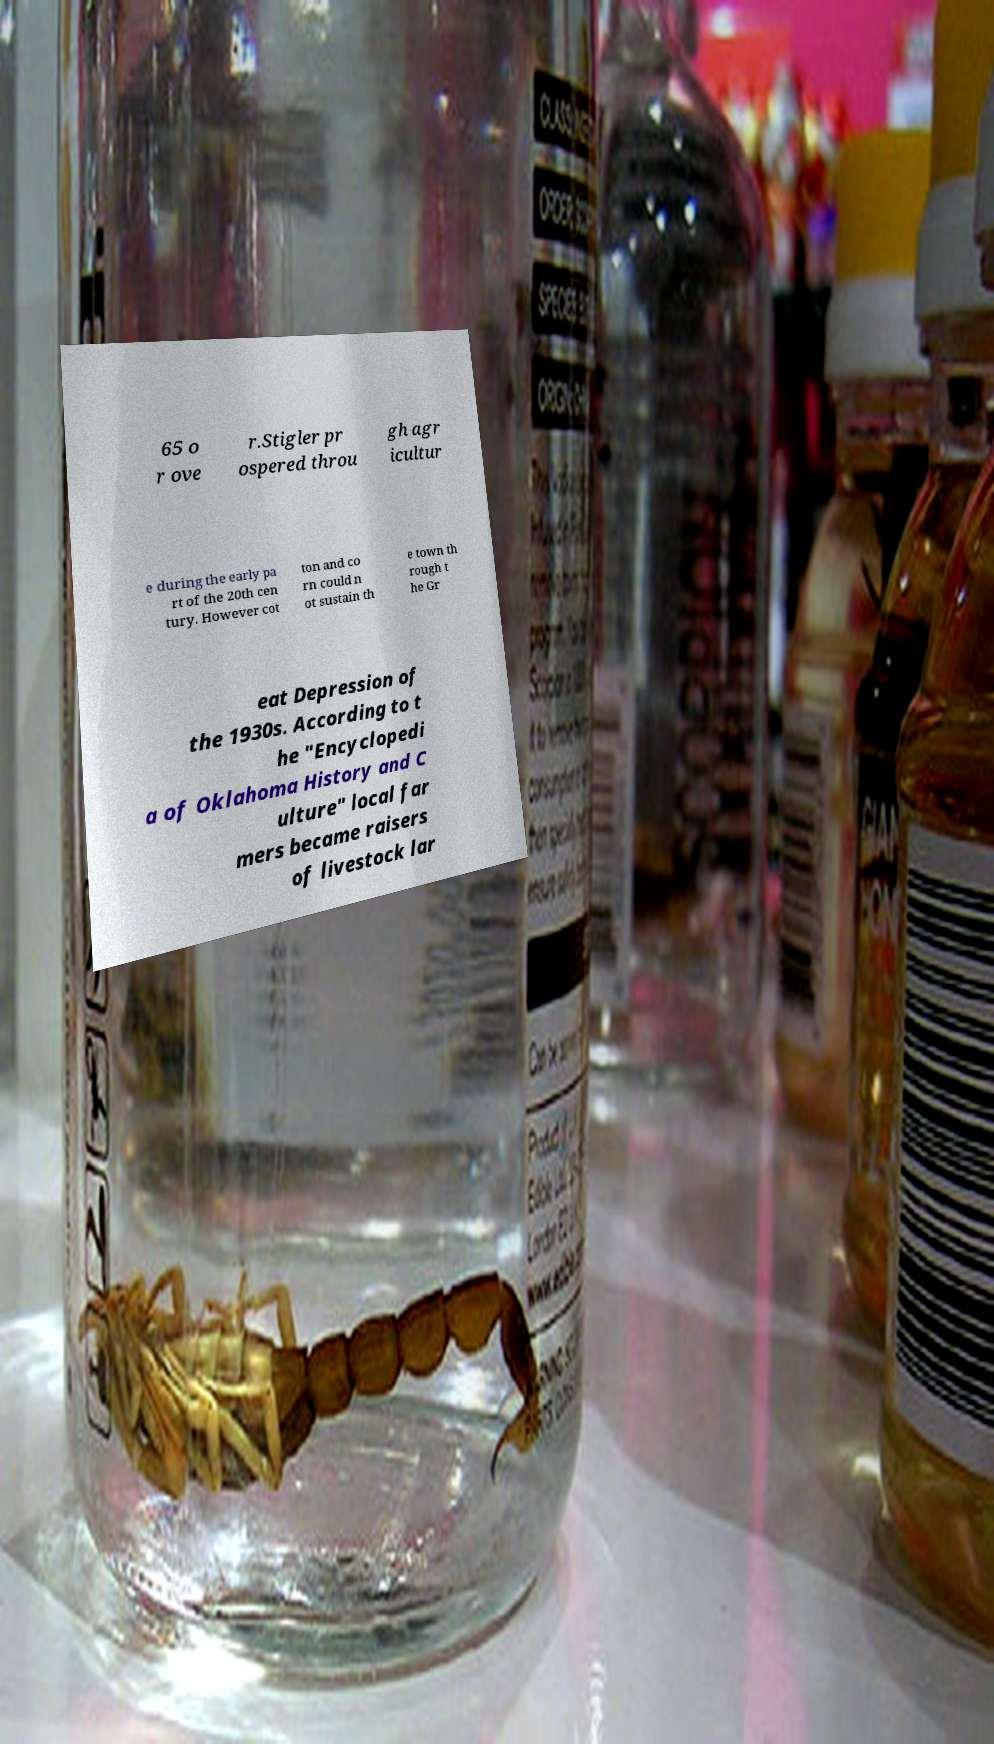Please read and relay the text visible in this image. What does it say? 65 o r ove r.Stigler pr ospered throu gh agr icultur e during the early pa rt of the 20th cen tury. However cot ton and co rn could n ot sustain th e town th rough t he Gr eat Depression of the 1930s. According to t he "Encyclopedi a of Oklahoma History and C ulture" local far mers became raisers of livestock lar 